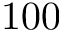<formula> <loc_0><loc_0><loc_500><loc_500>1 0 0</formula> 